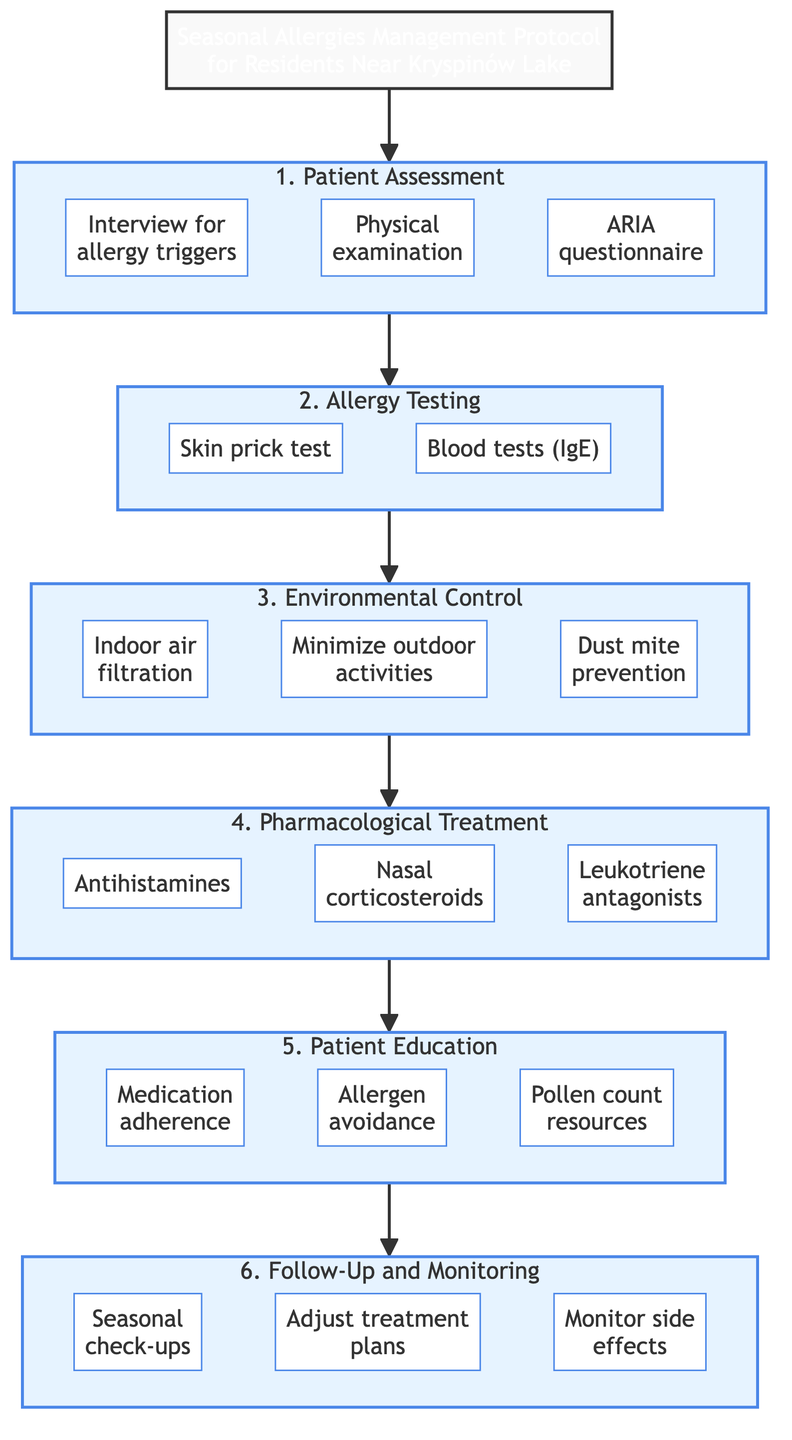What is the first step in the protocol? The diagram starts with the title leading into the first step, which is "Patient Assessment". This is the initial step of the Clinical Pathway.
Answer: Patient Assessment How many main steps are there in the protocol? By counting the steps in the diagram, there are six distinct main steps that are part of the Clinical Pathway.
Answer: 6 Name one pharmacological treatment listed in the protocol. In the Pharmacological Treatment step, one of the treatments listed is "Antihistamines". This indicates different options for medicinal management of allergies.
Answer: Antihistamines What is the last step in the Clinical Pathway? The diagram shows that the last main step that follows all previous steps is "Follow-Up and Monitoring". This indicates the concluding part of the protocol.
Answer: Follow-Up and Monitoring What should be conducted before pollen season? In the Follow-Up and Monitoring step, the diagram mentions "Seasonal check-ups". This implies a proactive assessment before allergy-triggering seasons.
Answer: Seasonal check-ups During which step are allergy tests performed? The diagram clearly indicates that the step focused on performing tests is titled "Allergy Testing". This is where diagnosis begins in the pathway.
Answer: Allergy Testing Which sub-step involves educating patients about allergen avoidance? In the Patient Education step, one of the sub-steps is "Allergen avoidance". This details part of the educational component for managing allergies.
Answer: Allergen avoidance What type of tests are suggested in the Allergy Testing step? The Allergy Testing step suggests "Skin prick test" and "Blood tests (IgE)" for identifying specific allergens. This emphasizes diagnostic methods.
Answer: Skin prick test What does the Environmental Control step aim to achieve? The purpose of the Environmental Control step is to "reduce allergen exposure," as outlined in the description. This step highlights preventative measures.
Answer: Reduce allergen exposure 